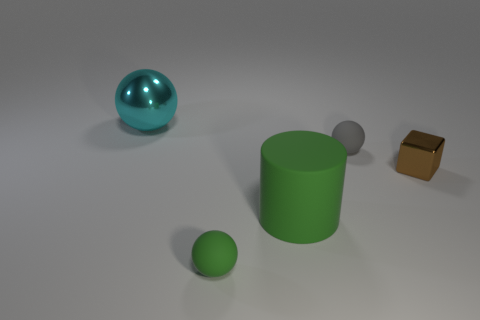What shape is the tiny brown object?
Make the answer very short. Cube. Is there any other thing that is the same material as the large green thing?
Provide a succinct answer. Yes. Do the brown thing and the cyan object have the same material?
Offer a terse response. Yes. There is a small rubber sphere that is in front of the small rubber ball that is right of the large green cylinder; are there any spheres that are to the right of it?
Your response must be concise. Yes. How many other objects are the same shape as the big cyan object?
Your response must be concise. 2. There is a tiny object that is in front of the tiny gray object and right of the rubber cylinder; what shape is it?
Ensure brevity in your answer.  Cube. What color is the tiny sphere that is in front of the metallic thing that is on the right side of the big thing that is on the left side of the tiny green thing?
Ensure brevity in your answer.  Green. Is the number of tiny matte balls that are in front of the small gray rubber object greater than the number of balls that are left of the large sphere?
Provide a short and direct response. Yes. How many other things are there of the same size as the shiny cube?
Keep it short and to the point. 2. The big object that is behind the big green thing that is in front of the gray object is made of what material?
Provide a short and direct response. Metal. 